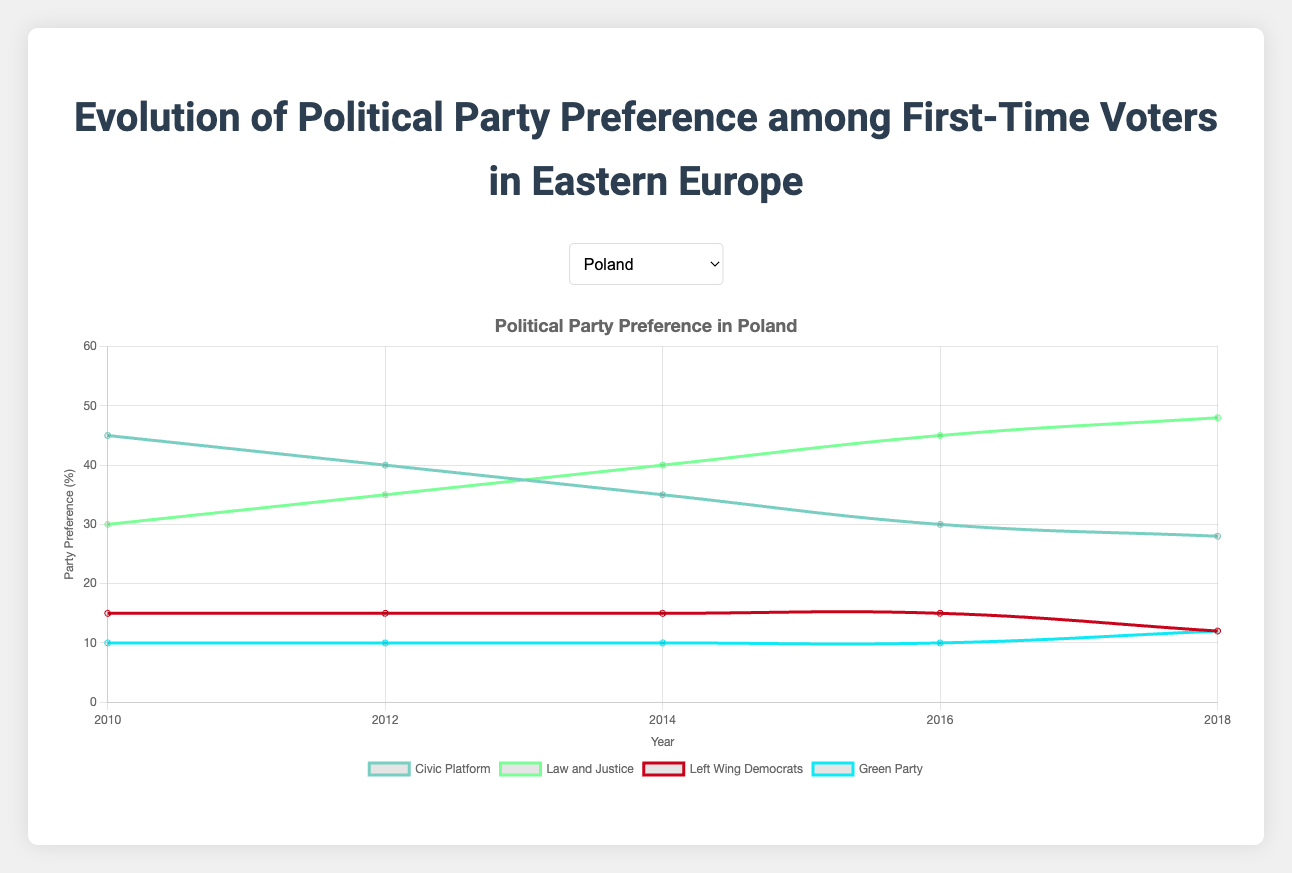Which political party had the highest preference among first-time voters in Poland in 2018? The highest preference can be determined by looking at the highest point on the graph for Poland in 2018. The Law and Justice party had 48%, which is higher than all other parties.
Answer: Law and Justice Which country had the largest increase in preference for a single political party between 2010 and 2018? Compute the increase for each party in each country. Fidesz in Hungary decreased from 50% to 36%, a 14% drop, not an increase. Jobbik increased from 20% to 30% in Hungary, a 10% increase. Czech Republic's ANO increased from 25% to 38%, a 13% increase. Social Democrats in Romania decreased, not increased. Bulgarian Socialist Party (BSP) increased from 30% to 37%, a 7% increase. So, ANO in the Czech Republic had the largest increase at 13%.
Answer: ANO in Czech Republic How did the party preference trend of the Civic Platform in Poland from 2010 to 2018 differ from that of the Fidesz in Hungary? Observe the trend lines for Civic Platform in Poland and Fidesz in Hungary from 2010 to 2018. Civic Platform shows a decreasing trend from 45% to 28%, while Fidesz also shows a decreasing trend from 50% to 36%. Both trends are decreasing, but Civic Platform's decline is more consistent.
Answer: Both parties saw a decline, but Civic Platform had a more consistent decrease Which party in Bulgaria had a consistent preference of around 20% from 2010 to 2018? Look at the trend lines for each party in Bulgaria and find which line stays around the 20% mark throughout the years. The Movement for Rights and Freedoms stays consistent at 20%-21%.
Answer: Movement for Rights and Freedoms Calculate the average party preference for the Union Save Romania party from 2010 to 2018. Add the percentages for each year (15 + 15 + 19 + 24 + 27) and divide by the number of years (5). (15 + 15 + 19 + 24 + 27) = 100, 100 / 5 = 20%.
Answer: 20% Compare the preference trends of the Left Wing Democrats in Poland and the Communist Party in the Czech Republic. Observe the trend lines for both Left Wing Democrats in Poland and Communist Party in the Czech Republic. Both parties show a relatively flat trend; Left Wing Democrats stays around 15% with a slight decrease to 12% in 2018, and the Communist Party fluctuates between 14% and 16%.
Answer: Both trends are relatively flat with slight fluctuations Which political party had the smallest change in preference in Romania between 2010 and 2018? Calculate the differences in percentages for each party from 2010 to 2018. Social Democrats went from 35% to 30% (5% decrease), National Liberals from 30% to 23% (7% decrease), Democratic Liberal Party remained at 20% (no change), and Union Save Romania went from 15% to 27% (12% increase). The Democratic Liberal Party had no change.
Answer: Democratic Liberal Party What is the median preference for the Green Party in Poland from 2010 to 2018? List the preferences in order and find the middle value. The preferences are (10, 10, 10, 10, 12). The middle value (median) is 10.
Answer: 10 Which two political parties in Hungary had almost identical preference values in any year between 2010 to 2018? Look for overlapping lines or points where party preferences are the same or very close. In 2010, Socialist Party and Jobbik both had 20% preference.
Answer: Socialist Party and Jobbik (2010) What was the largest decrease in preference for any party in Poland from one year to the next? Calculate the year-by-year differences for each party. The largest sequential decrease was for Civic Platform from 2010 (45%) to 2012 (40%), a 5% drop.
Answer: Civic Platform (5% drop from 2010 to 2012) 